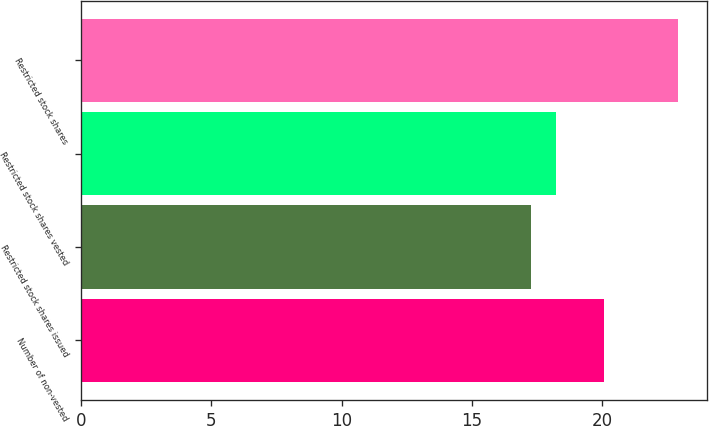Convert chart. <chart><loc_0><loc_0><loc_500><loc_500><bar_chart><fcel>Number of non-vested<fcel>Restricted stock shares issued<fcel>Restricted stock shares vested<fcel>Restricted stock shares<nl><fcel>20.08<fcel>17.27<fcel>18.23<fcel>22.89<nl></chart> 